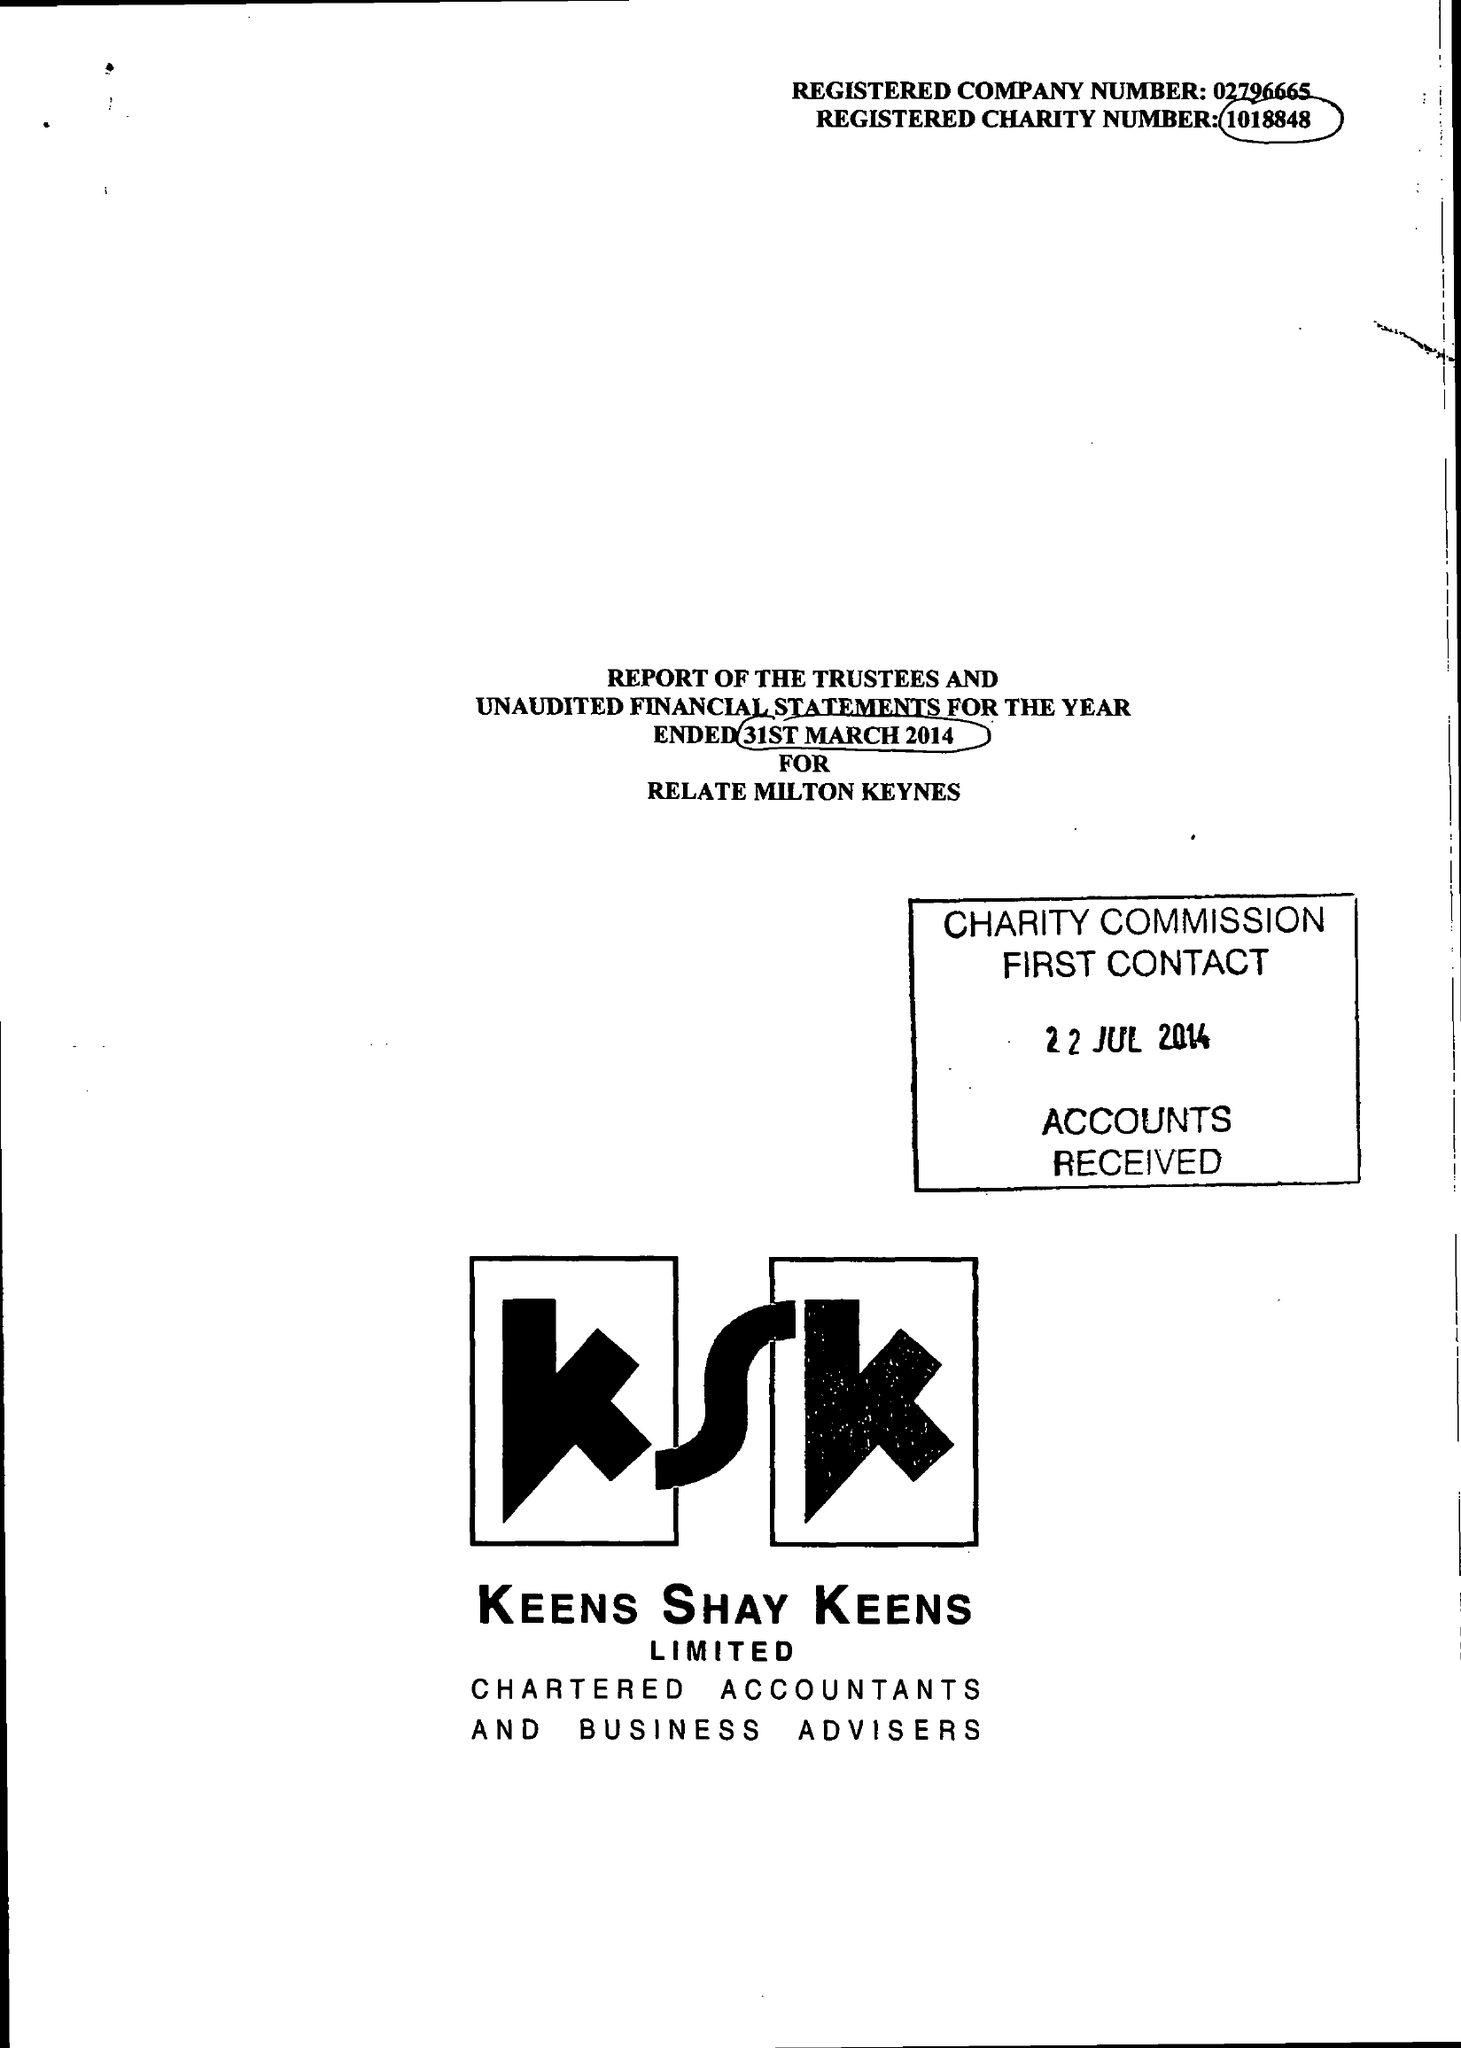What is the value for the spending_annually_in_british_pounds?
Answer the question using a single word or phrase. 196925.00 